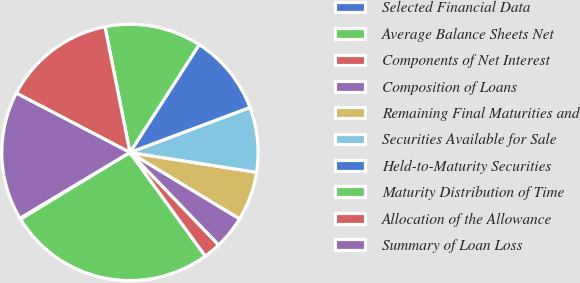Convert chart. <chart><loc_0><loc_0><loc_500><loc_500><pie_chart><fcel>Selected Financial Data<fcel>Average Balance Sheets Net<fcel>Components of Net Interest<fcel>Composition of Loans<fcel>Remaining Final Maturities and<fcel>Securities Available for Sale<fcel>Held-to-Maturity Securities<fcel>Maturity Distribution of Time<fcel>Allocation of the Allowance<fcel>Summary of Loan Loss<nl><fcel>0.15%<fcel>26.28%<fcel>2.16%<fcel>4.17%<fcel>6.18%<fcel>8.19%<fcel>10.2%<fcel>12.21%<fcel>14.22%<fcel>16.23%<nl></chart> 